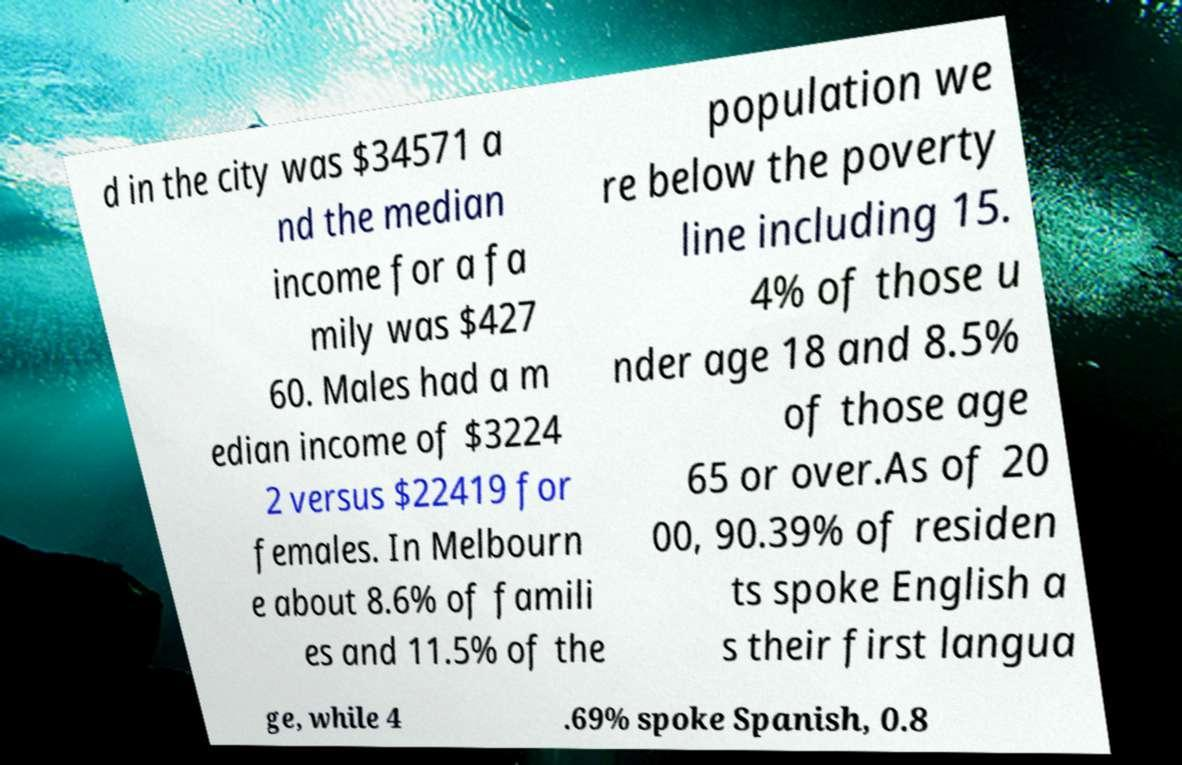Could you extract and type out the text from this image? d in the city was $34571 a nd the median income for a fa mily was $427 60. Males had a m edian income of $3224 2 versus $22419 for females. In Melbourn e about 8.6% of famili es and 11.5% of the population we re below the poverty line including 15. 4% of those u nder age 18 and 8.5% of those age 65 or over.As of 20 00, 90.39% of residen ts spoke English a s their first langua ge, while 4 .69% spoke Spanish, 0.8 